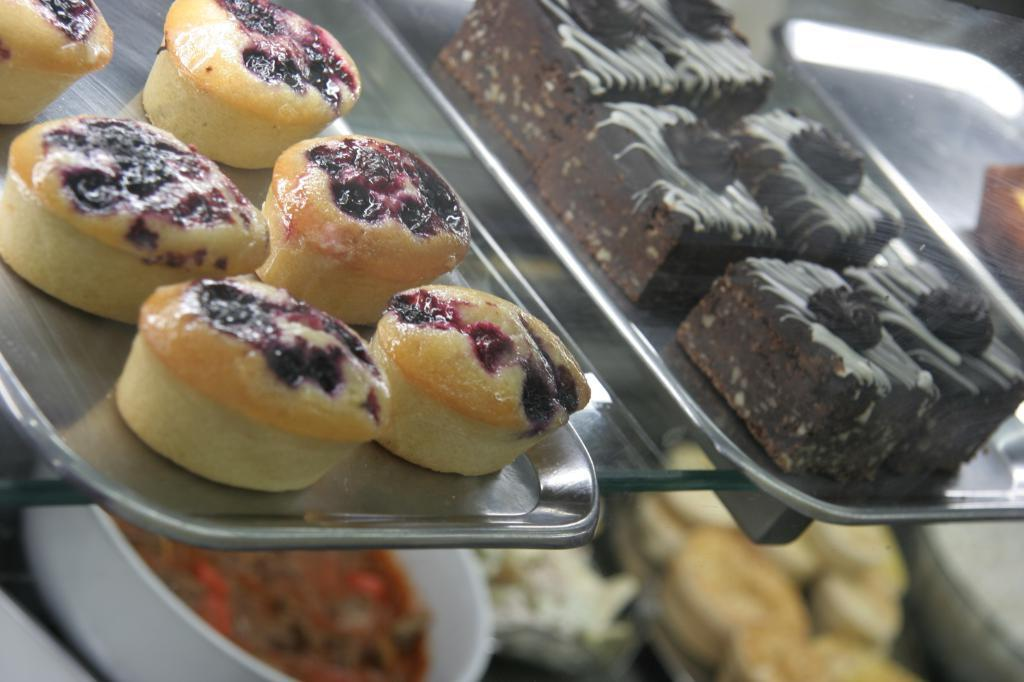What objects are present on the plates in the image? The plates contain cakes. Can you describe the contents of the plates in the image? The plates contain cakes. How many kittens are sitting on the cakes in the image? There are no kittens present in the image; the plates contain cakes only. 